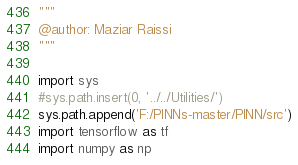<code> <loc_0><loc_0><loc_500><loc_500><_Python_>"""
@author: Maziar Raissi
"""

import sys
#sys.path.insert(0, '../../Utilities/')
sys.path.append('F:/PINNs-master/PINN/src')
import tensorflow as tf
import numpy as np</code> 